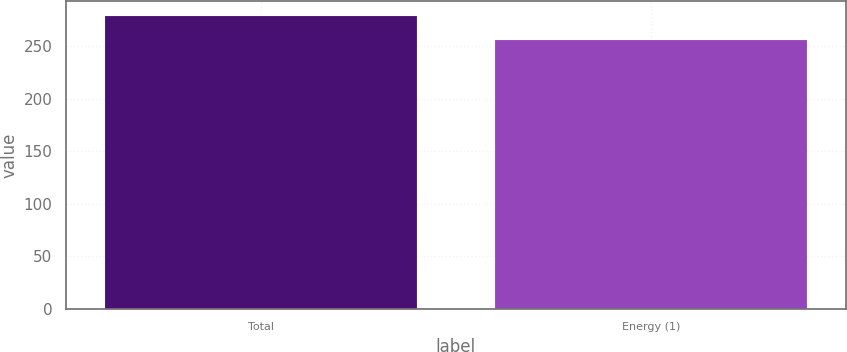<chart> <loc_0><loc_0><loc_500><loc_500><bar_chart><fcel>Total<fcel>Energy (1)<nl><fcel>279<fcel>256<nl></chart> 